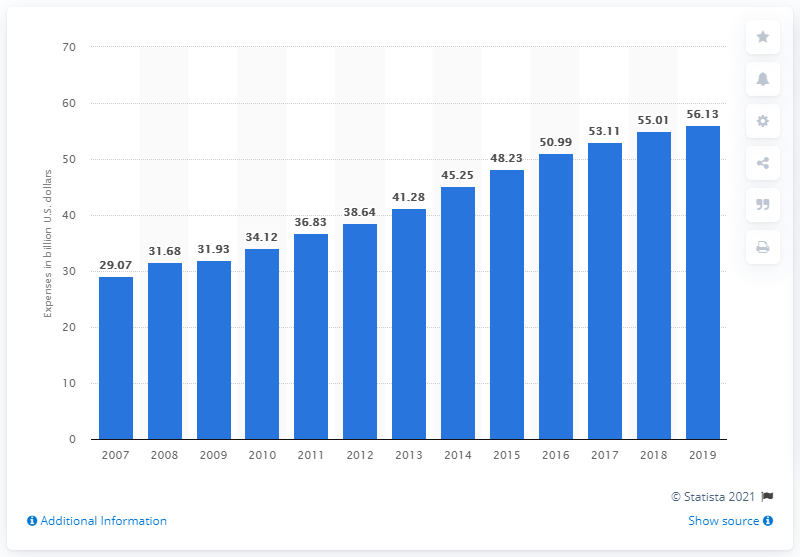Highlight a few significant elements in this photo. In 2018, cable and pay TV providers spent approximately 55.01 In the United States in 2019, the expenses of cable and pay TV providers totaled $56.13 billion. 